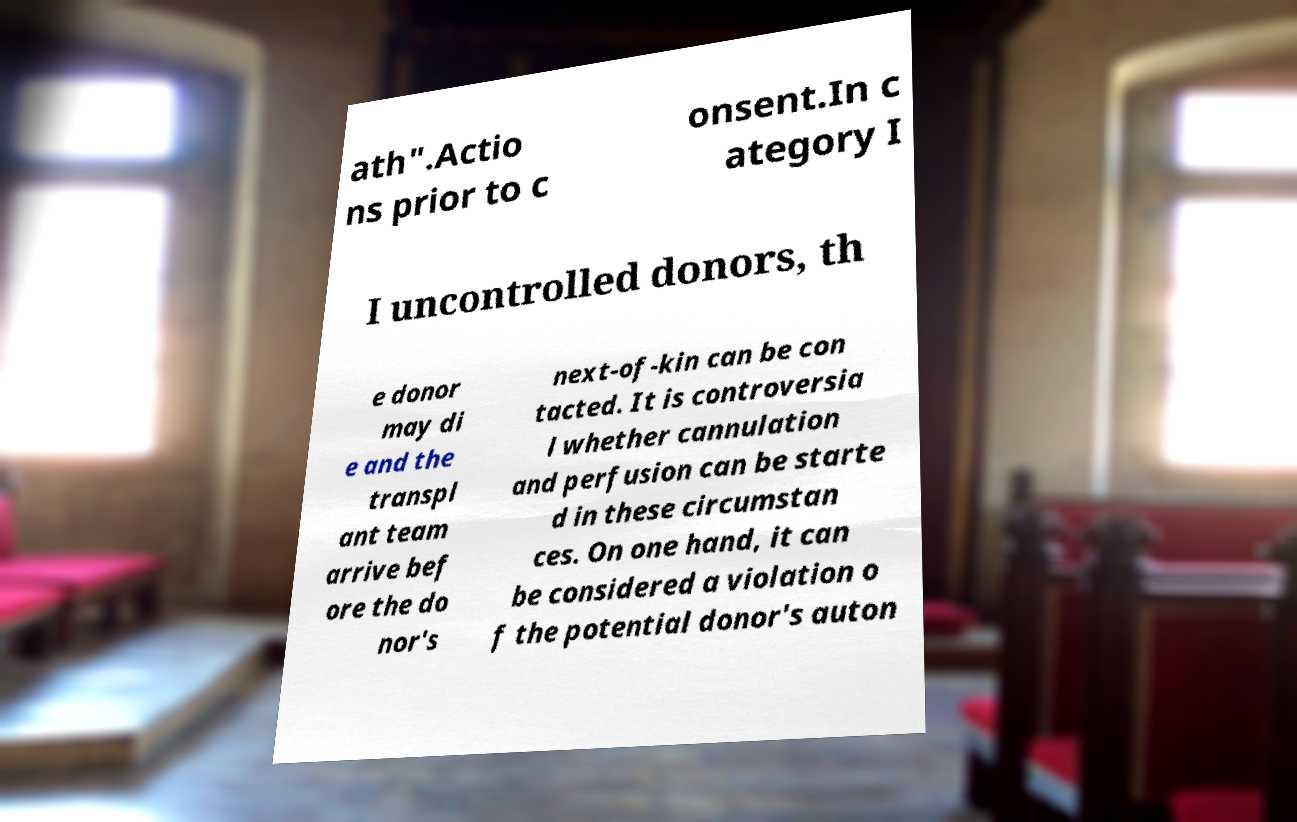There's text embedded in this image that I need extracted. Can you transcribe it verbatim? ath".Actio ns prior to c onsent.In c ategory I I uncontrolled donors, th e donor may di e and the transpl ant team arrive bef ore the do nor's next-of-kin can be con tacted. It is controversia l whether cannulation and perfusion can be starte d in these circumstan ces. On one hand, it can be considered a violation o f the potential donor's auton 